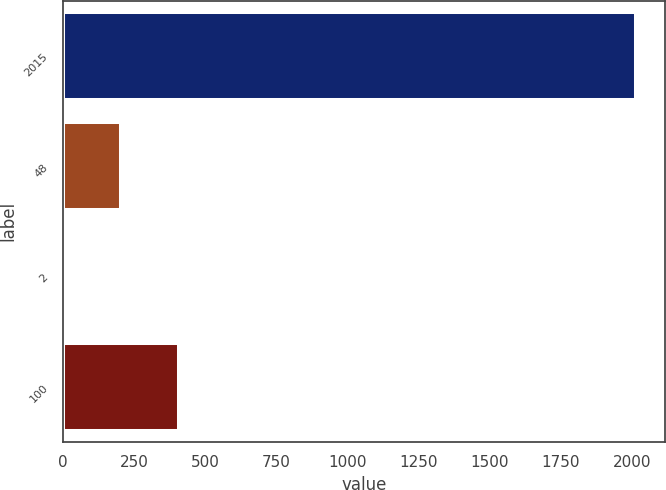Convert chart. <chart><loc_0><loc_0><loc_500><loc_500><bar_chart><fcel>2015<fcel>48<fcel>2<fcel>100<nl><fcel>2015<fcel>206<fcel>5<fcel>407<nl></chart> 